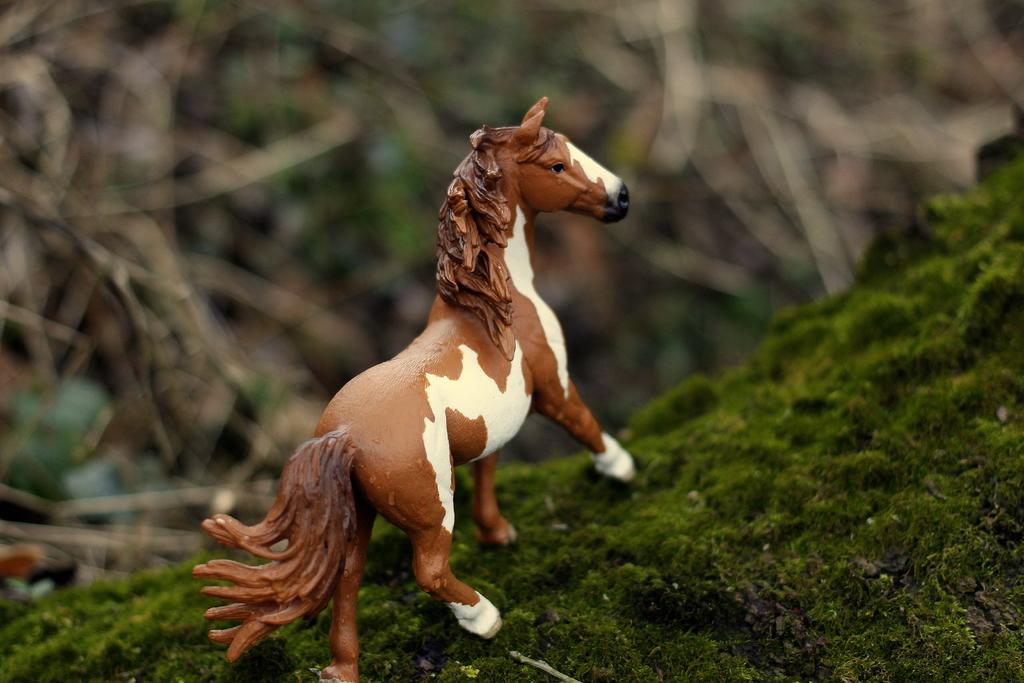What type of toy is visible in the image? There is a horse toy in the image. Can you describe the background of the image? The background of the image is blurred. What type of lumber is being used during the recess in the image? There is no recess or lumber present in the image; it features a horse toy with a blurred background. 